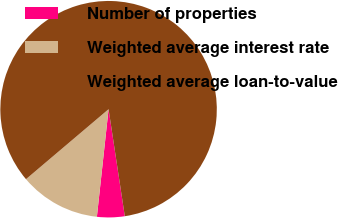<chart> <loc_0><loc_0><loc_500><loc_500><pie_chart><fcel>Number of properties<fcel>Weighted average interest rate<fcel>Weighted average loan-to-value<nl><fcel>4.12%<fcel>12.09%<fcel>83.79%<nl></chart> 